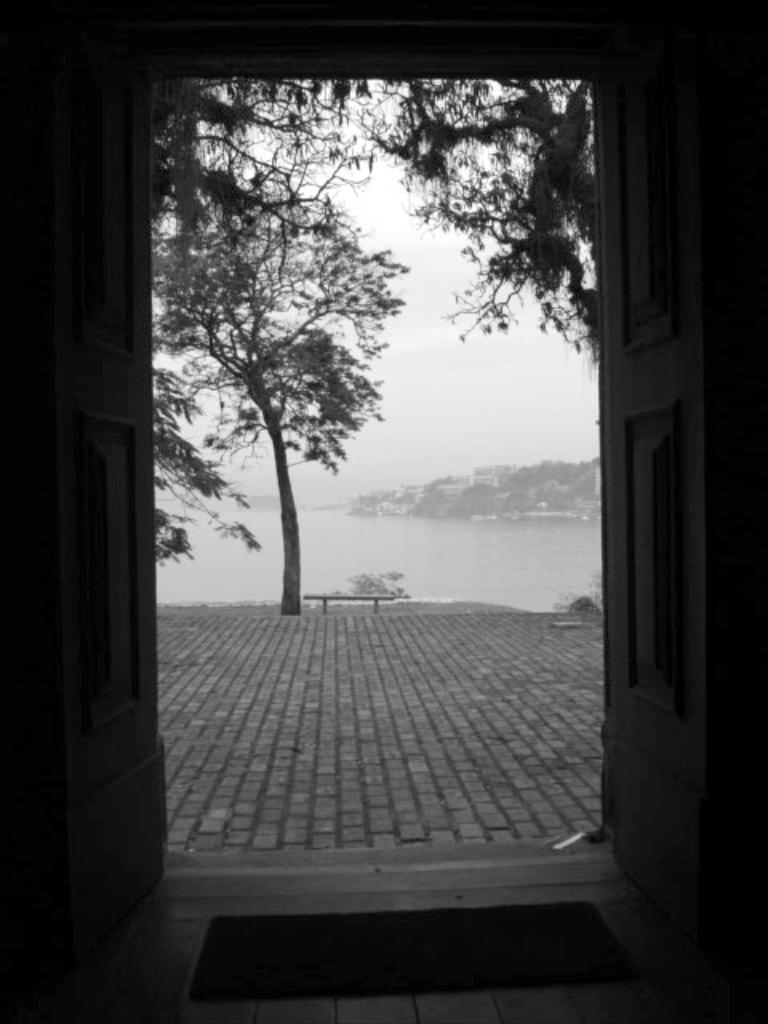What is the color scheme of the image? The image is black and white. What can be found inside the buildings in the background? The provided facts do not give information about what is inside the buildings in the background. What is on the floor in the image? There is a mat on the floor in the image. What is the weather like in the image? The presence of trees, water, and the sky visible in the background suggests that it is a sunny day. How many gloves can be seen hanging on the trees in the image? There are no gloves visible in the image; it features trees, water, and buildings in the background. Are there any stockings hanging from the bench in the image? There are no stockings present in the image; it features a bench, mat, doors, and trees on the ground. 